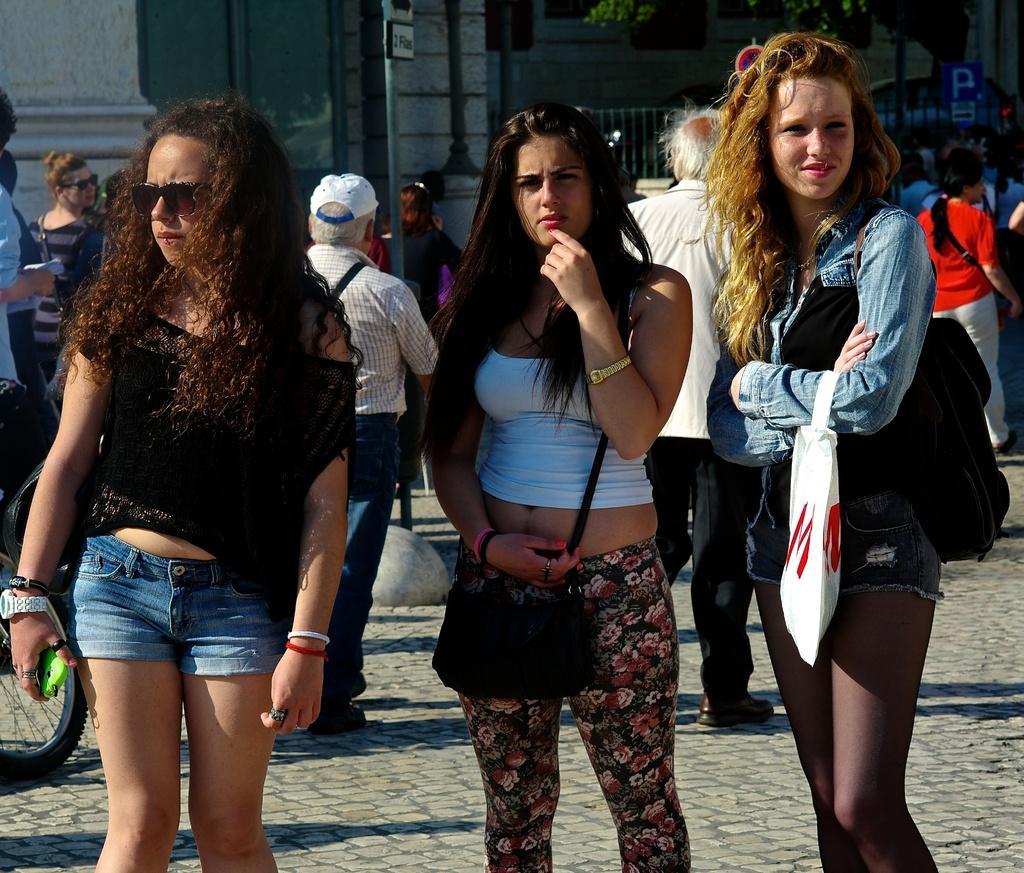Could you give a brief overview of what you see in this image? In this picture we can see three girls are standing in the front, in the background there are some people walking, we can see a tree, a board, a building, fencing panel in the background, at the left bottom we can see a tyre, a girl on the right side is carrying a backpack and a hand bag. 